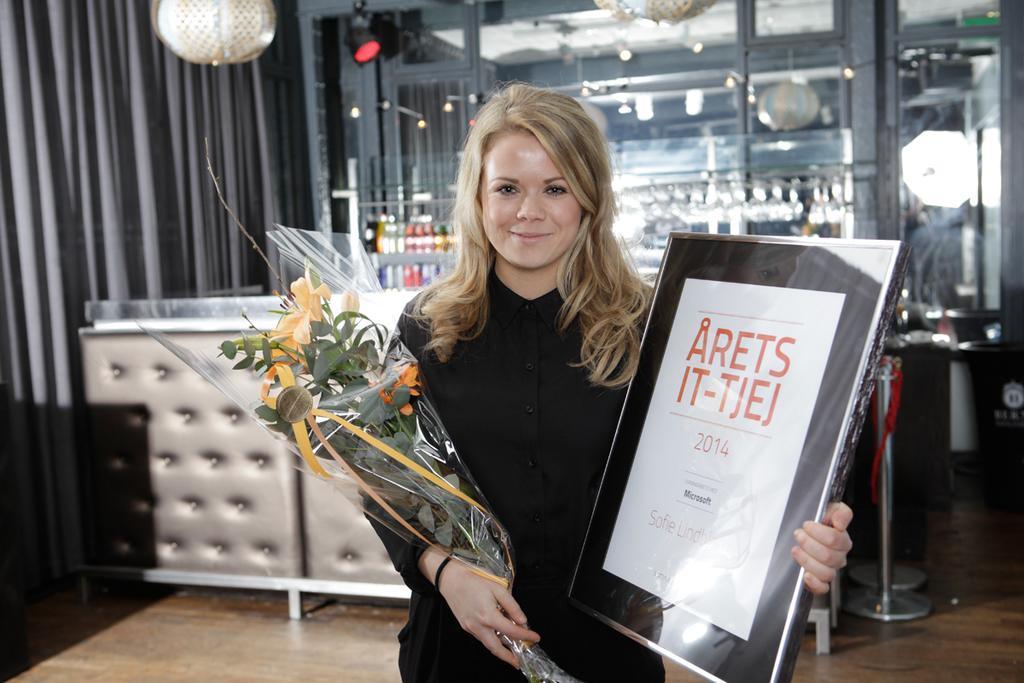How would you summarize this image in a sentence or two? In this image, I can see the woman standing and smiling. She is holding a flower bouquet and a frame in her hands. This looks like a table. In the background, I can see few objects and a glass door. I think these are the curtains hanging. Here is the floor. On the right side of the image, that looks like a dustbin. 